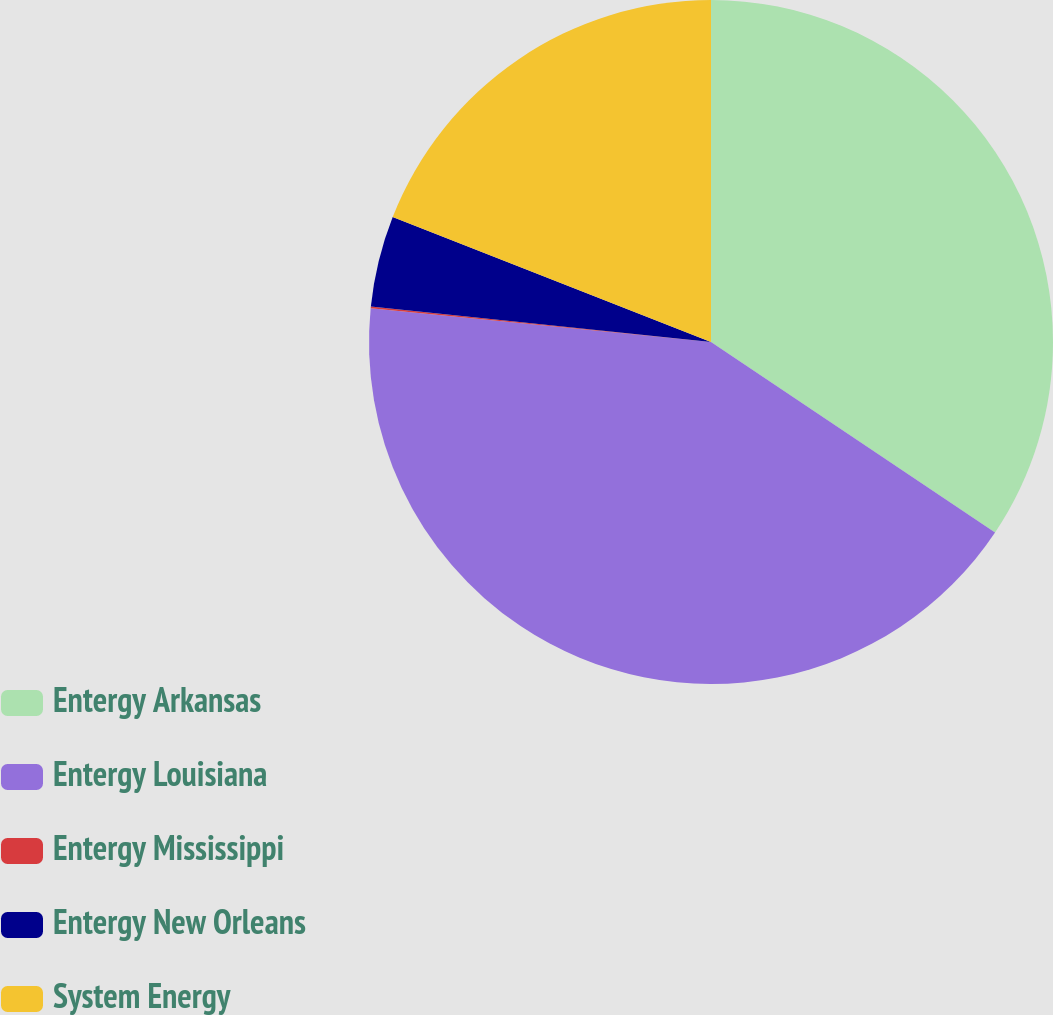Convert chart to OTSL. <chart><loc_0><loc_0><loc_500><loc_500><pie_chart><fcel>Entergy Arkansas<fcel>Entergy Louisiana<fcel>Entergy Mississippi<fcel>Entergy New Orleans<fcel>System Energy<nl><fcel>34.4%<fcel>42.17%<fcel>0.09%<fcel>4.3%<fcel>19.04%<nl></chart> 